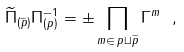Convert formula to latex. <formula><loc_0><loc_0><loc_500><loc_500>\widetilde { \Pi } _ { ( \widetilde { p } ) } \Pi _ { ( p ) } ^ { - 1 } = \pm \prod _ { m \in \, p \sqcup { \widetilde { p } } } \Gamma ^ { m } \ ,</formula> 